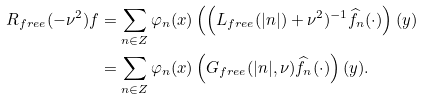Convert formula to latex. <formula><loc_0><loc_0><loc_500><loc_500>R _ { f r e e } ( - \nu ^ { 2 } ) f & = \sum _ { n \in { Z } } \varphi _ { n } ( x ) \left ( \Big ( L _ { f r e e } ( | n | ) + \nu ^ { 2 } ) ^ { - 1 } \widehat { f } _ { n } ( \cdot ) \right ) ( y ) \\ & = \sum _ { n \in { Z } } \varphi _ { n } ( x ) \left ( G _ { f r e e } ( | n | , \nu ) \widehat { f } _ { n } ( \cdot ) \right ) ( y ) .</formula> 